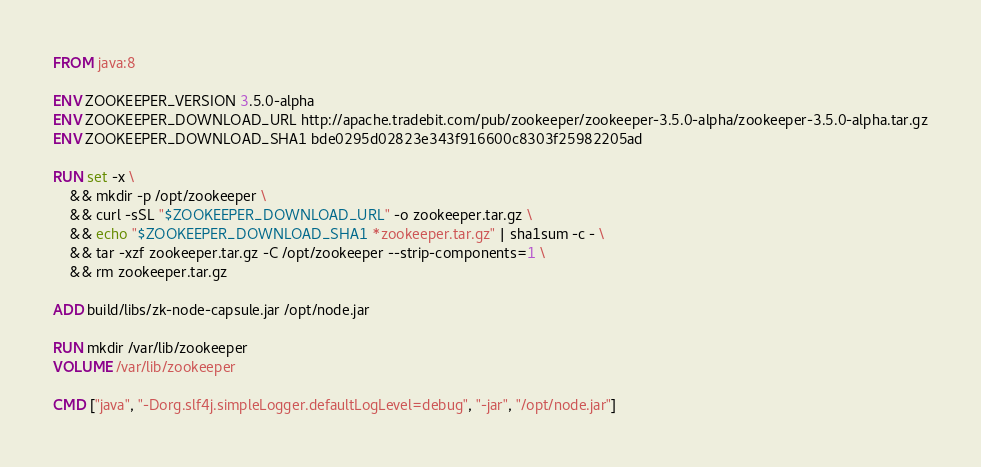<code> <loc_0><loc_0><loc_500><loc_500><_Dockerfile_>FROM java:8

ENV ZOOKEEPER_VERSION 3.5.0-alpha
ENV ZOOKEEPER_DOWNLOAD_URL http://apache.tradebit.com/pub/zookeeper/zookeeper-3.5.0-alpha/zookeeper-3.5.0-alpha.tar.gz
ENV ZOOKEEPER_DOWNLOAD_SHA1 bde0295d02823e343f916600c8303f25982205ad

RUN set -x \
	&& mkdir -p /opt/zookeeper \
    && curl -sSL "$ZOOKEEPER_DOWNLOAD_URL" -o zookeeper.tar.gz \
    && echo "$ZOOKEEPER_DOWNLOAD_SHA1 *zookeeper.tar.gz" | sha1sum -c - \
    && tar -xzf zookeeper.tar.gz -C /opt/zookeeper --strip-components=1 \
    && rm zookeeper.tar.gz

ADD build/libs/zk-node-capsule.jar /opt/node.jar

RUN mkdir /var/lib/zookeeper
VOLUME /var/lib/zookeeper

CMD ["java", "-Dorg.slf4j.simpleLogger.defaultLogLevel=debug", "-jar", "/opt/node.jar"]</code> 